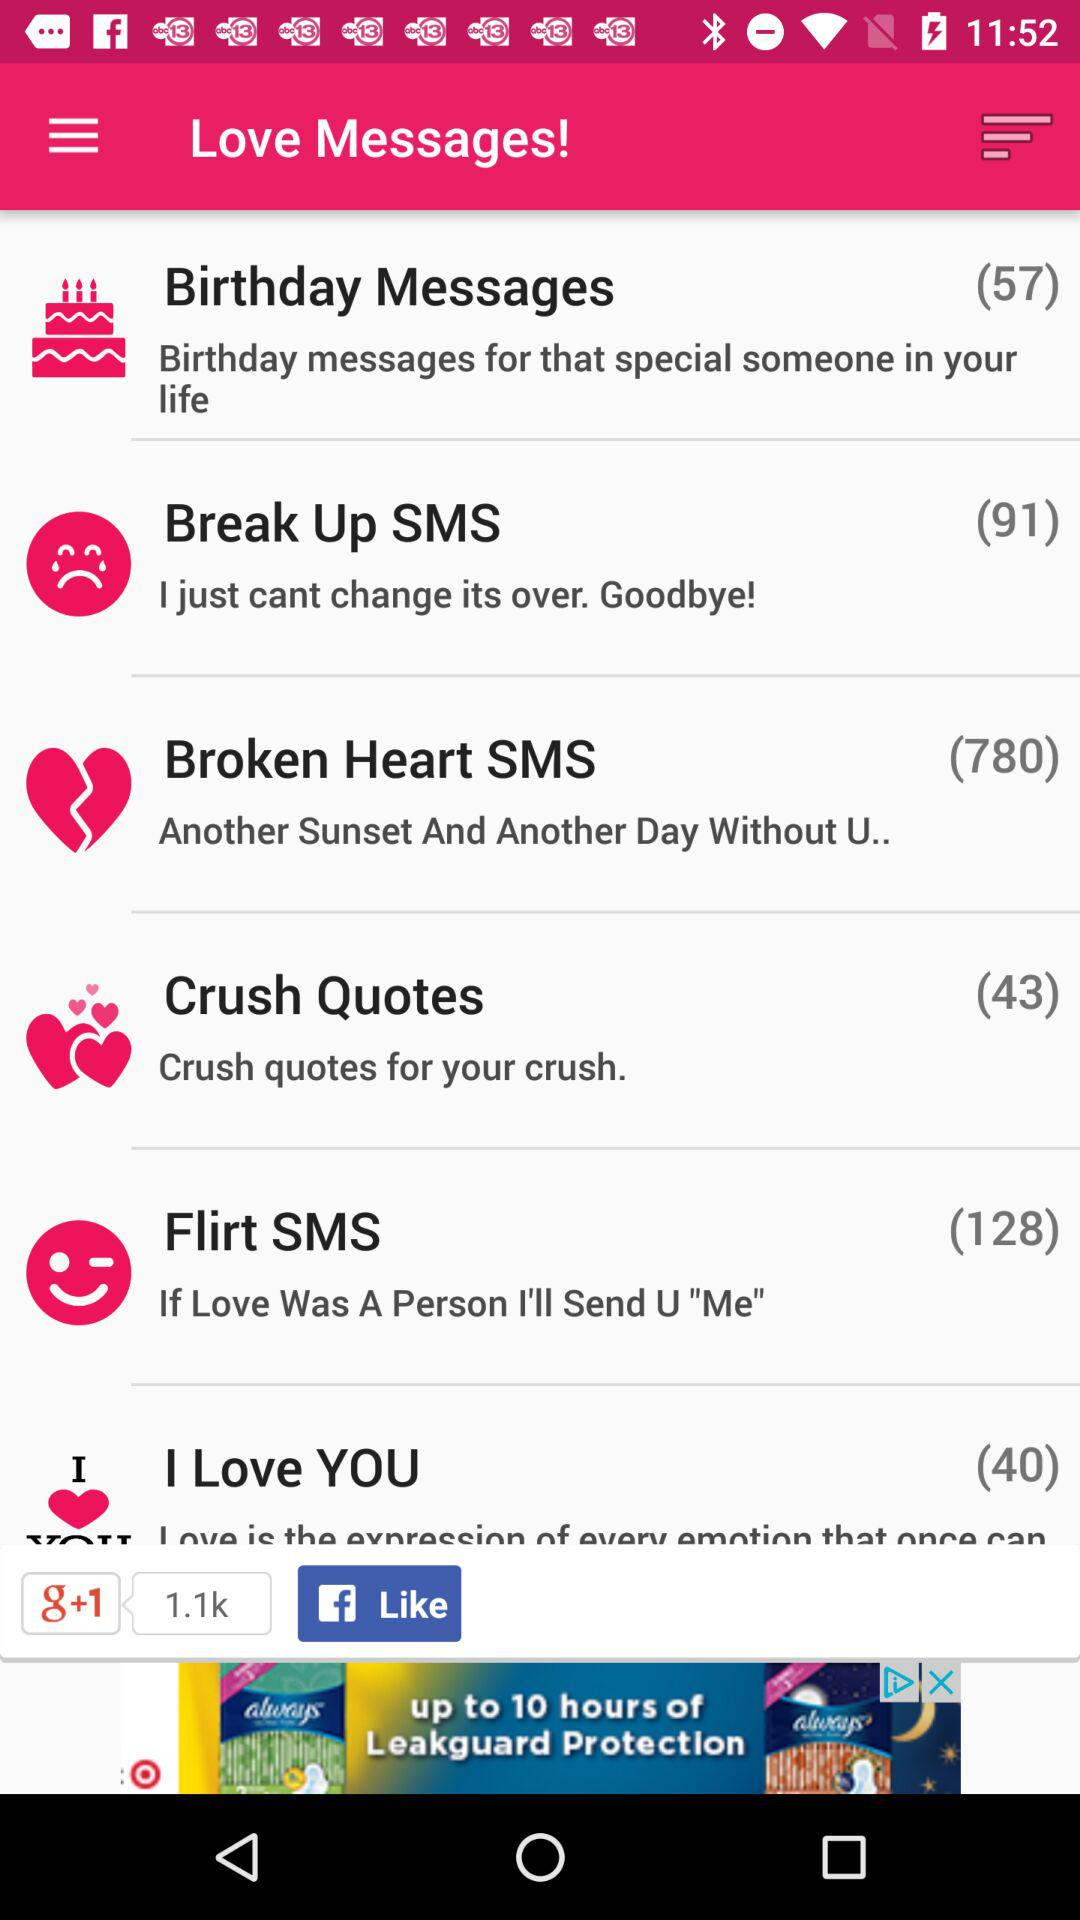What is mentioned in "Flirt SMS"? In "Flirt SMS", "If Love Was A Person I'll Send U "Me"" is mentioned. 